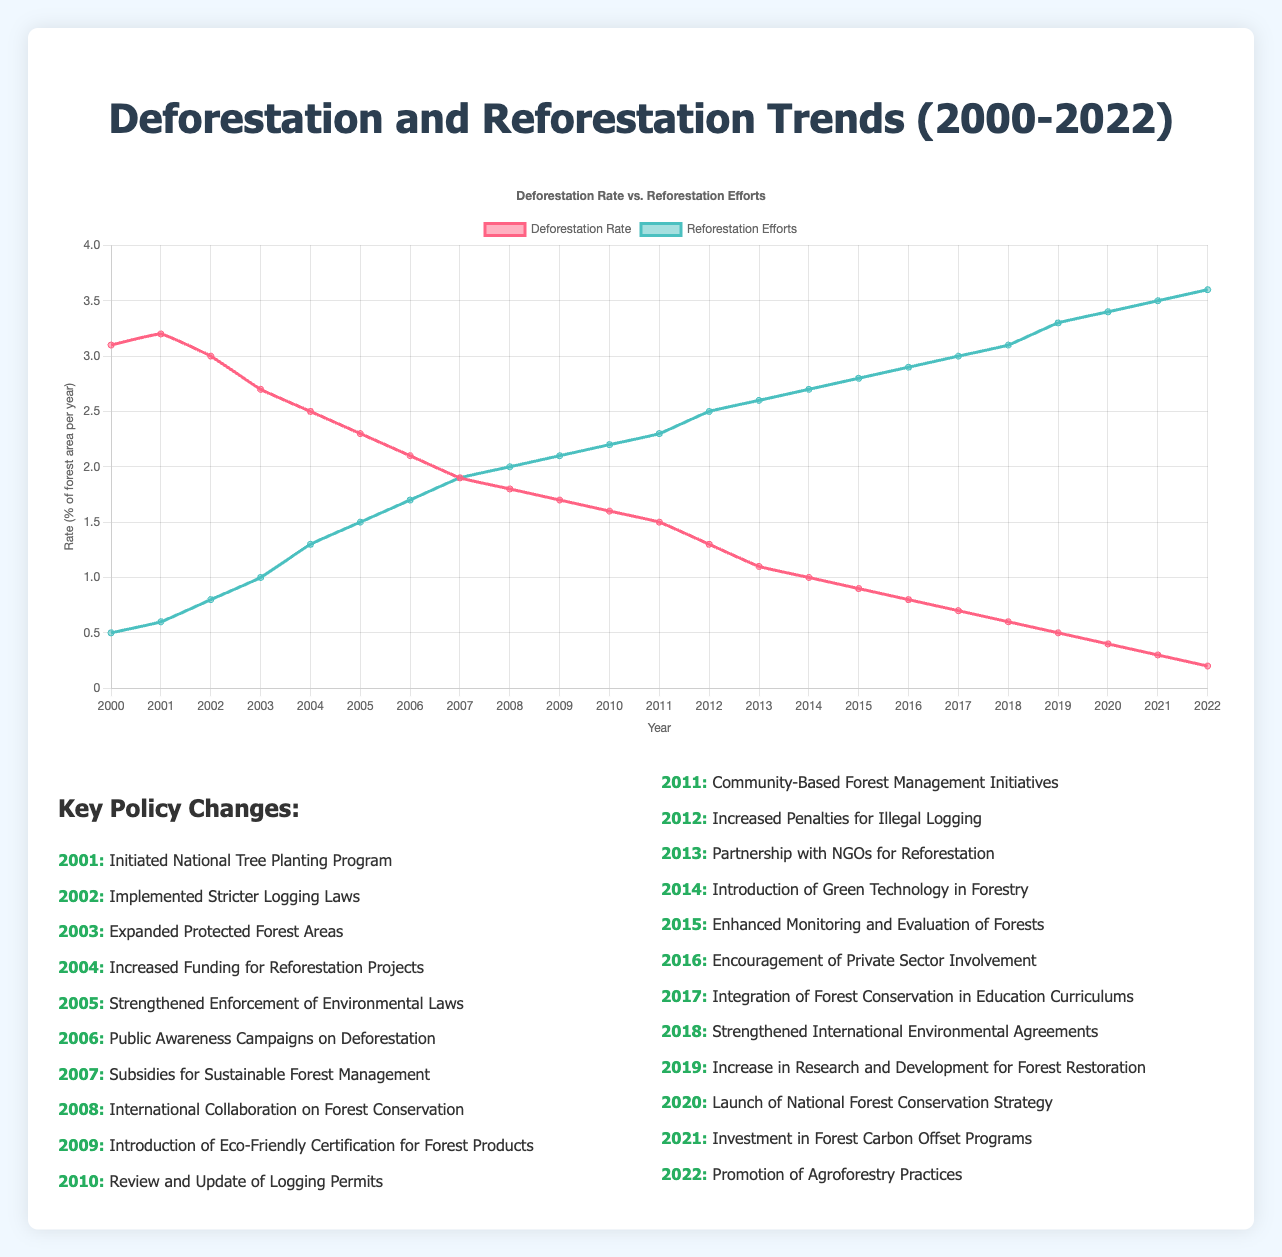What year had the highest deforestation rate? From the line plot, the deforestation rate is highest in the year 2001. This is visually indicated by the peak of the red line.
Answer: 2001 By how much did the reforestation efforts increase from 2006 to 2022? In 2006, reforestation efforts were at 1.7%. By 2022, they increased to 3.6%. The increase can be calculated as 3.6 - 1.7 = 1.9%.
Answer: 1.9% Which year first saw equal rates of deforestation and reforestation efforts? By observing the intersection of the red and green lines, we see that in 2007 the deforestation rate equaled the reforestation efforts at 1.9%.
Answer: 2007 How did deforestation rates change in the year immediately following the implementation of the "Strengthened Enforcement of Environmental Laws"? "Strengthened Enforcement of Environmental Laws" was implemented in 2005. From 2005 to 2006, the deforestation rate dropped from 2.3% to 2.1%.
Answer: Dropped by 0.2% What is the visual difference between the trend lines for deforestation and reforestation efforts? The red line representing deforestation steadily decreases over time, while the green line representing reforestation gradually increases.
Answer: Decreasing vs Increasing What are the average annual deforestation and reforestation efforts between 2010 and 2020? For deforestation: (1.6+1.5+1.3+1.1+1.0+0.9+0.8+0.7+0.6+0.5+0.4)/11 = 1.05%. For reforestation: (2.2+2.3+2.5+2.6+2.7+2.8+2.9+3.0+3.1+3.3+3.4)/11 = 2.82%.
Answer: Deforestation: 1.05%, Reforestation: 2.82% In which year did the deforestation rate drop below 1% for the first time? Observing the red line, the deforestation rate drops below 1% for the first time in 2014.
Answer: 2014 What is the gap between deforestation and reforestation rates in 2020? In 2020, the deforestation rate was 0.4% and the reforestation rate was 3.4%. The gap is calculated as 3.4% - 0.4% = 3.0%.
Answer: 3.0% 